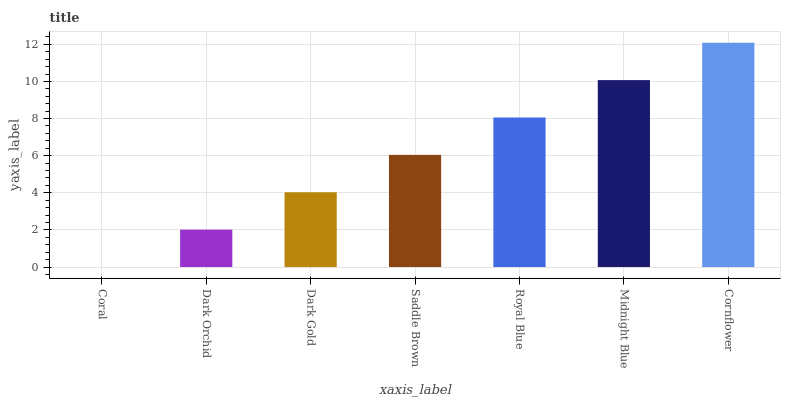Is Coral the minimum?
Answer yes or no. Yes. Is Cornflower the maximum?
Answer yes or no. Yes. Is Dark Orchid the minimum?
Answer yes or no. No. Is Dark Orchid the maximum?
Answer yes or no. No. Is Dark Orchid greater than Coral?
Answer yes or no. Yes. Is Coral less than Dark Orchid?
Answer yes or no. Yes. Is Coral greater than Dark Orchid?
Answer yes or no. No. Is Dark Orchid less than Coral?
Answer yes or no. No. Is Saddle Brown the high median?
Answer yes or no. Yes. Is Saddle Brown the low median?
Answer yes or no. Yes. Is Royal Blue the high median?
Answer yes or no. No. Is Midnight Blue the low median?
Answer yes or no. No. 